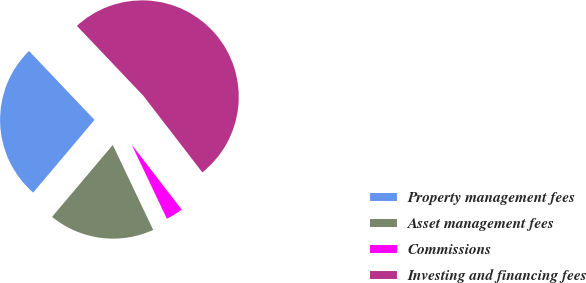Convert chart. <chart><loc_0><loc_0><loc_500><loc_500><pie_chart><fcel>Property management fees<fcel>Asset management fees<fcel>Commissions<fcel>Investing and financing fees<nl><fcel>26.75%<fcel>18.22%<fcel>3.38%<fcel>51.64%<nl></chart> 